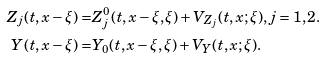Convert formula to latex. <formula><loc_0><loc_0><loc_500><loc_500>Z _ { j } ( t , x - \xi ) = & Z _ { j } ^ { 0 } ( t , x - \xi , \xi ) + V _ { Z _ { j } } ( t , x ; \xi ) , j = 1 , 2 . \\ Y ( t , x - \xi ) = & Y _ { 0 } ( t , x - \xi , \xi ) + V _ { Y } ( t , x ; \xi ) .</formula> 